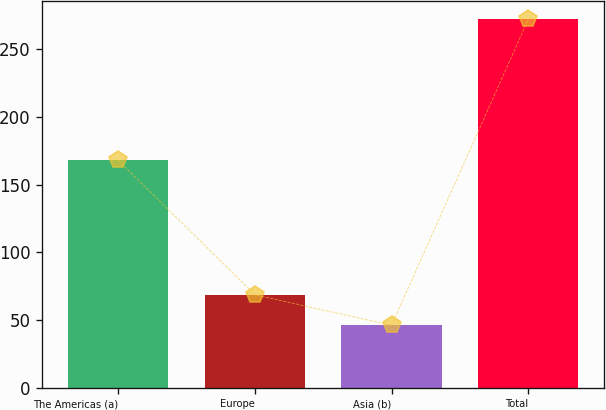<chart> <loc_0><loc_0><loc_500><loc_500><bar_chart><fcel>The Americas (a)<fcel>Europe<fcel>Asia (b)<fcel>Total<nl><fcel>168<fcel>68.6<fcel>46<fcel>272<nl></chart> 